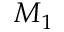Convert formula to latex. <formula><loc_0><loc_0><loc_500><loc_500>M _ { 1 }</formula> 